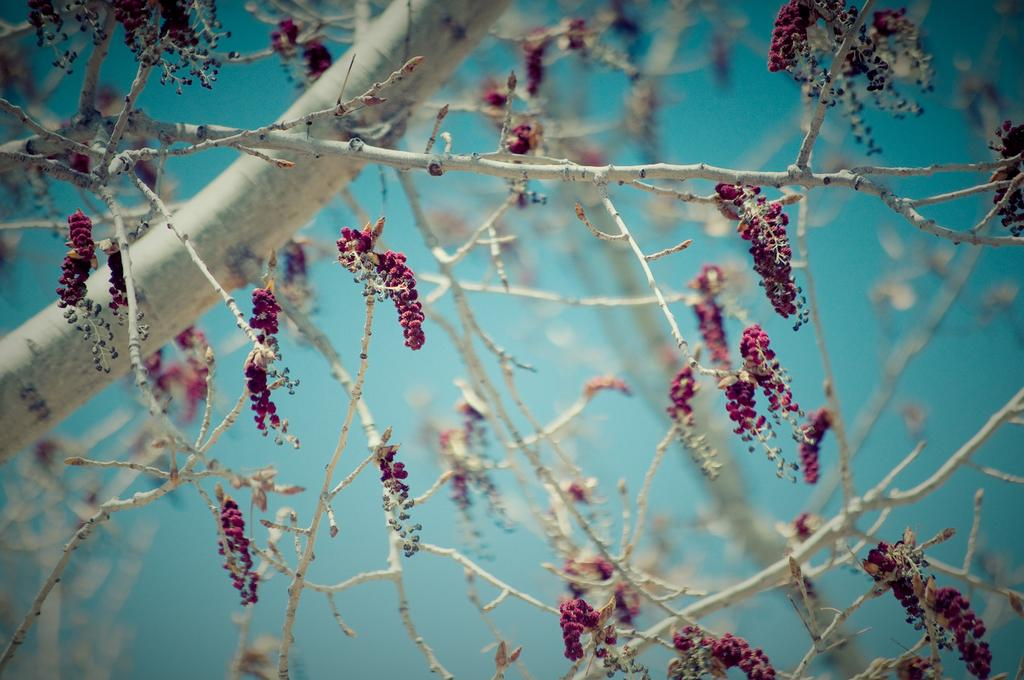What type of vegetation can be seen on the tree in the image? There are flowers on the tree in the image. What type of wax can be seen dripping from the stars in the image? There are no stars or wax present in the image; it features a tree with flowers. 